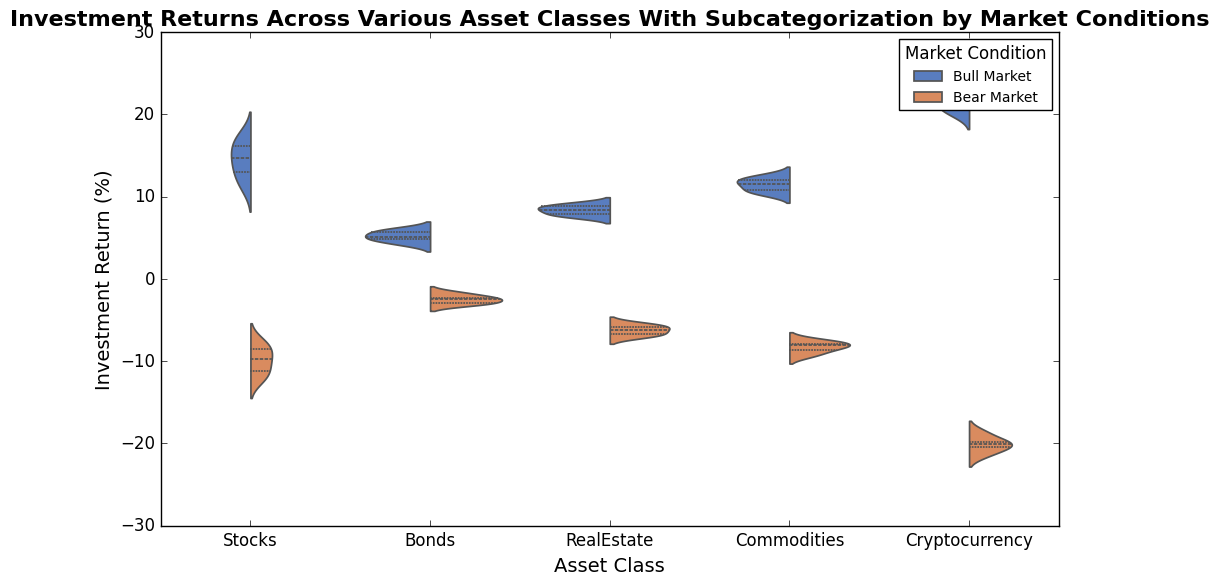What is the median return for stocks during a bull market? To find the median return for stocks during a bull market, look at the violin plot section for "Stocks" under "Bull Market". The inner quartile markers show that the median line is slightly above the middle point of the violin. Typically, in a violin plot, the median is marked with a line within the wider interquartile bar.
Answer: Approximately 14.7% Which asset class has the highest median return in a bear market? To determine which asset class has the highest median return in a bear market, examine the middle lines of the violins under the "Bear Market" condition. The line that appears the highest indicates the asset with the highest median return. For this case, Bonds and Real Estate have higher median lines compared to other asset classes in a bear market.
Answer: Bonds How does the spread of returns for cryptocurrencies in a bear market compare to stocks in a bear market? Compare the width and shape of the violins for "Cryptocurrency" and "Stocks" under the "Bear Market" category. The wider the violin, the more variable the data. For cryptocurrencies, the violin is relatively wide, indicating a large spread, whereas the violin for stocks is narrower and more consistent, showing less spread.
Answer: Cryptocurrencies have a larger spread What is the general shape of the return distribution for commodities in a bull market? Observe the shape of the violin for commodities under the bull market condition. The shape of the violin plot indicates the distribution pattern. For commodities, it generally shows a balanced spread around the center, with symmetrical bulging in the middle parts and tapering at the ends, indicating a typical distribution with moderate central tendency.
Answer: Symmetrical with central bulging In which market condition do stocks have a wider range of returns, bull market or bear market? To compare the range of returns for stocks under bull and bear market conditions, observe the full extent of the violin shapes from bottom to top in both conditions. The range is given by the total span of each violin. In this case, the bear market violin is wider and extends more, indicating a larger range compared to the bull market.
Answer: Bear market Compare the median returns for real estate in both bull and bear markets. To compare the median returns, look at the inner lines of the violins for Real Estate under both market conditions. The median line in the bull market is higher than that in the bear market.
Answer: Higher in bull market Which asset class experiences the most negative median returns during a bear market? Examine the median lines for each asset class's violin plot under the bear market. The lowest median line indicates the most negative median returns. In this case, cryptocurrencies have the lowest median, dipping further into negative territory compared to other asset classes.
Answer: Cryptocurrency 